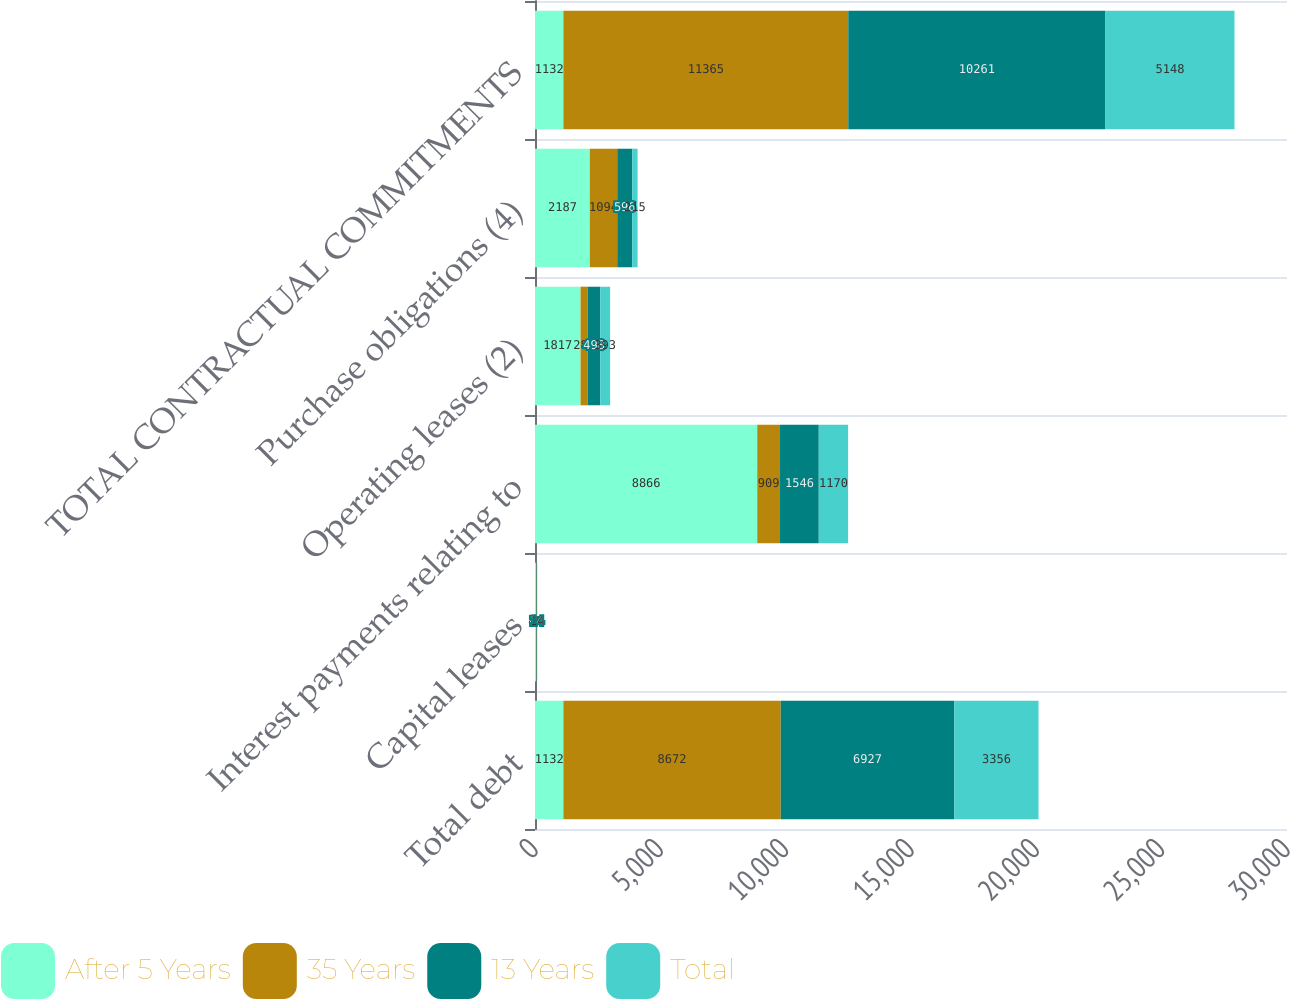<chart> <loc_0><loc_0><loc_500><loc_500><stacked_bar_chart><ecel><fcel>Total debt<fcel>Capital leases<fcel>Interest payments relating to<fcel>Operating leases (2)<fcel>Purchase obligations (4)<fcel>TOTAL CONTRACTUAL COMMITMENTS<nl><fcel>After 5 Years<fcel>1132<fcel>45<fcel>8866<fcel>1817<fcel>2187<fcel>1132<nl><fcel>35 Years<fcel>8672<fcel>16<fcel>909<fcel>289<fcel>1094<fcel>11365<nl><fcel>13 Years<fcel>6927<fcel>14<fcel>1546<fcel>498<fcel>596<fcel>10261<nl><fcel>Total<fcel>3356<fcel>14<fcel>1170<fcel>393<fcel>215<fcel>5148<nl></chart> 